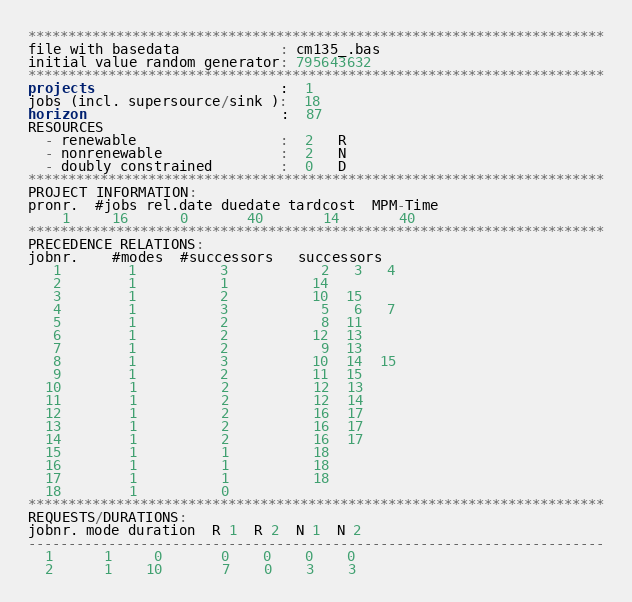Convert code to text. <code><loc_0><loc_0><loc_500><loc_500><_ObjectiveC_>************************************************************************
file with basedata            : cm135_.bas
initial value random generator: 795643632
************************************************************************
projects                      :  1
jobs (incl. supersource/sink ):  18
horizon                       :  87
RESOURCES
  - renewable                 :  2   R
  - nonrenewable              :  2   N
  - doubly constrained        :  0   D
************************************************************************
PROJECT INFORMATION:
pronr.  #jobs rel.date duedate tardcost  MPM-Time
    1     16      0       40       14       40
************************************************************************
PRECEDENCE RELATIONS:
jobnr.    #modes  #successors   successors
   1        1          3           2   3   4
   2        1          1          14
   3        1          2          10  15
   4        1          3           5   6   7
   5        1          2           8  11
   6        1          2          12  13
   7        1          2           9  13
   8        1          3          10  14  15
   9        1          2          11  15
  10        1          2          12  13
  11        1          2          12  14
  12        1          2          16  17
  13        1          2          16  17
  14        1          2          16  17
  15        1          1          18
  16        1          1          18
  17        1          1          18
  18        1          0        
************************************************************************
REQUESTS/DURATIONS:
jobnr. mode duration  R 1  R 2  N 1  N 2
------------------------------------------------------------------------
  1      1     0       0    0    0    0
  2      1    10       7    0    3    3</code> 